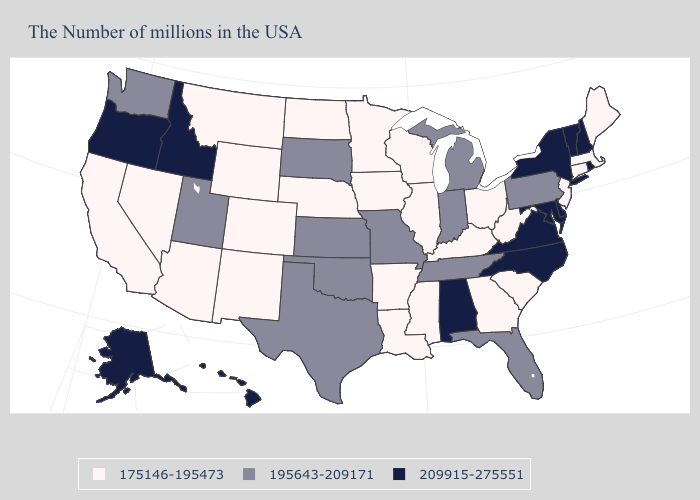Name the states that have a value in the range 209915-275551?
Short answer required. Rhode Island, New Hampshire, Vermont, New York, Delaware, Maryland, Virginia, North Carolina, Alabama, Idaho, Oregon, Alaska, Hawaii. What is the lowest value in the MidWest?
Concise answer only. 175146-195473. Name the states that have a value in the range 195643-209171?
Keep it brief. Pennsylvania, Florida, Michigan, Indiana, Tennessee, Missouri, Kansas, Oklahoma, Texas, South Dakota, Utah, Washington. Name the states that have a value in the range 209915-275551?
Answer briefly. Rhode Island, New Hampshire, Vermont, New York, Delaware, Maryland, Virginia, North Carolina, Alabama, Idaho, Oregon, Alaska, Hawaii. Name the states that have a value in the range 175146-195473?
Answer briefly. Maine, Massachusetts, Connecticut, New Jersey, South Carolina, West Virginia, Ohio, Georgia, Kentucky, Wisconsin, Illinois, Mississippi, Louisiana, Arkansas, Minnesota, Iowa, Nebraska, North Dakota, Wyoming, Colorado, New Mexico, Montana, Arizona, Nevada, California. What is the value of Tennessee?
Write a very short answer. 195643-209171. How many symbols are there in the legend?
Short answer required. 3. Among the states that border Nevada , which have the highest value?
Be succinct. Idaho, Oregon. Among the states that border Arizona , which have the lowest value?
Keep it brief. Colorado, New Mexico, Nevada, California. Does Kentucky have a lower value than Oregon?
Quick response, please. Yes. Does Kentucky have the lowest value in the South?
Be succinct. Yes. Does New Hampshire have the lowest value in the USA?
Concise answer only. No. Does Idaho have the lowest value in the West?
Quick response, please. No. What is the highest value in the South ?
Keep it brief. 209915-275551. 